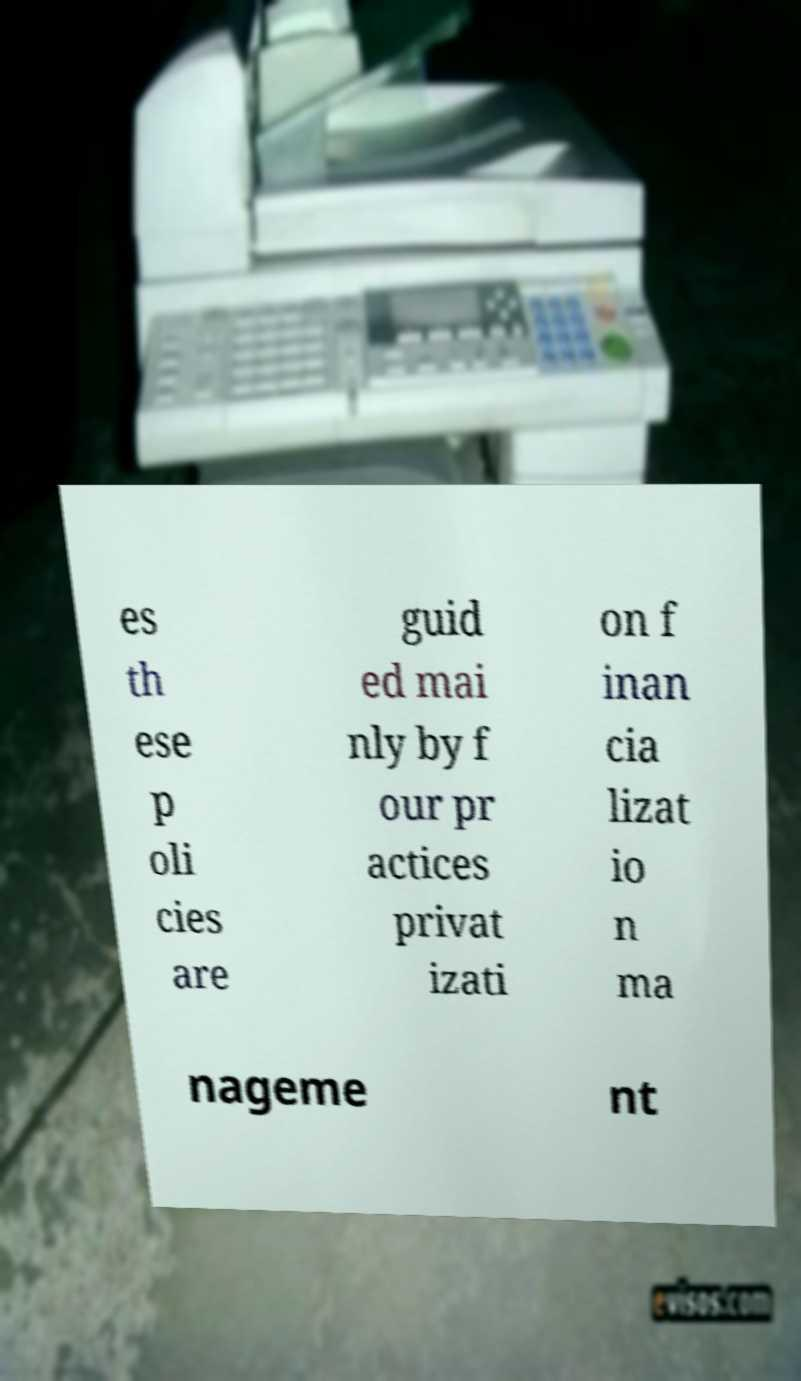Could you assist in decoding the text presented in this image and type it out clearly? es th ese p oli cies are guid ed mai nly by f our pr actices privat izati on f inan cia lizat io n ma nageme nt 